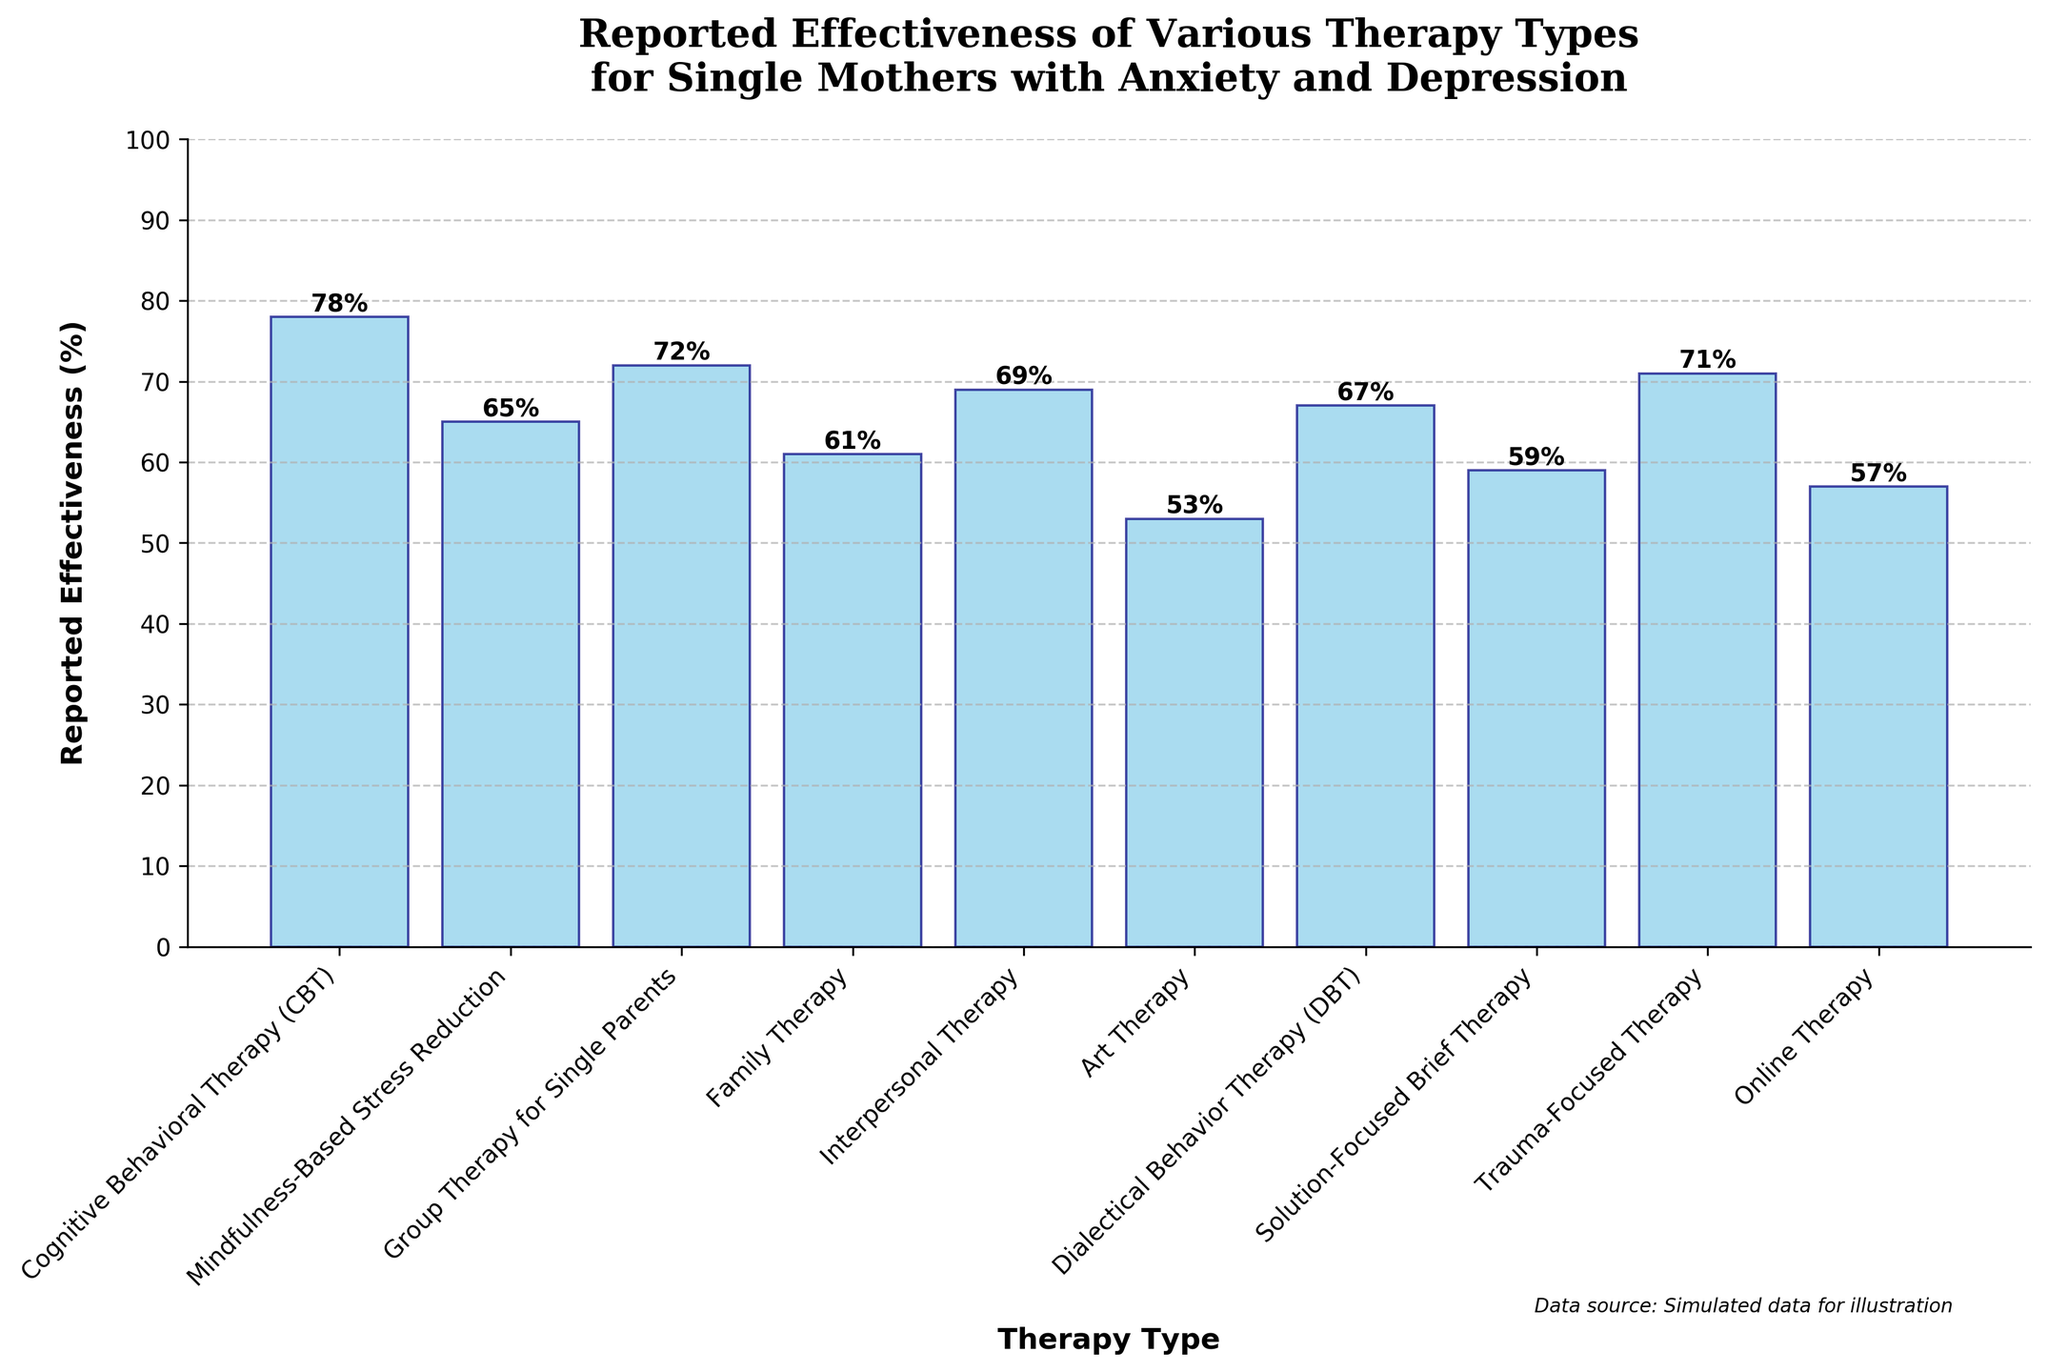What is the title of the figure? The title is located at the top of the figure and provides a summary of what the figure represents. It reads: "Reported Effectiveness of Various Therapy Types for Single Mothers with Anxiety and Depression."
Answer: Reported Effectiveness of Various Therapy Types for Single Mothers with Anxiety and Depression Which therapy type is reported to be the most effective for single mothers with anxiety and depression? By looking at the height of the bars, the tallest bar represents the highest reported effectiveness. The Cognitive Behavioral Therapy (CBT) bar is the tallest with 78% effectiveness.
Answer: Cognitive Behavioral Therapy (CBT) What is the reported effectiveness of Art Therapy? The bar corresponding to Art Therapy shows the height indicating its effectiveness. It is labeled with 53%.
Answer: 53% Which therapies have a reported effectiveness greater than 70%? To find the therapies with over 70% effectiveness, look at the bars with heights above this threshold. Cognitive Behavioral Therapy (78%), Group Therapy for Single Parents (72%), and Trauma-Focused Therapy (71%) meet this criterion.
Answer: Cognitive Behavioral Therapy (CBT), Group Therapy for Single Parents, Trauma-Focused Therapy How does Online Therapy's effectiveness compare to Family Therapy? Compare the heights of the bars for Online Therapy and Family Therapy. Online Therapy has a reported effectiveness of 57%, while Family Therapy has 61%. Family Therapy is more effective by 4%.
Answer: Family Therapy is more effective by 4% What is the average reported effectiveness of all the listed therapy types? Add up all the effectiveness percentages and divide by the number of therapy types. (78 + 65 + 72 + 61 + 69 + 53 + 67 + 59 + 71 + 57) / 10 = 65.2
Answer: 65.2% Is there any therapy type with exactly 65% effectiveness? Look for the bar with a height corresponding to 65%. Mindfulness-Based Stress Reduction has a reported effectiveness of 65%.
Answer: Mindfulness-Based Stress Reduction What is the difference in reported effectiveness between Trauma-Focused Therapy and Solution-Focused Brief Therapy? Subtract the reported effectiveness of Solution-Focused Brief Therapy (59%) from Trauma-Focused Therapy (71%): 71 - 59 = 12.
Answer: 12% Rank the top three most effective therapies for single mothers with anxiety and depression. Identify and rank the top three highest bars. They are Cognitive Behavioral Therapy (78%), Group Therapy for Single Parents (72%), and Trauma-Focused Therapy (71%).
Answer: Cognitive Behavioral Therapy (CBT), Group Therapy for Single Parents, Trauma-Focused Therapy How many therapies have reported effectiveness below 60%? Count the number of bars with heights below 60%. They include Art Therapy (53%), Solution-Focused Brief Therapy (59%), and Online Therapy (57%), totaling three therapies.
Answer: Three 